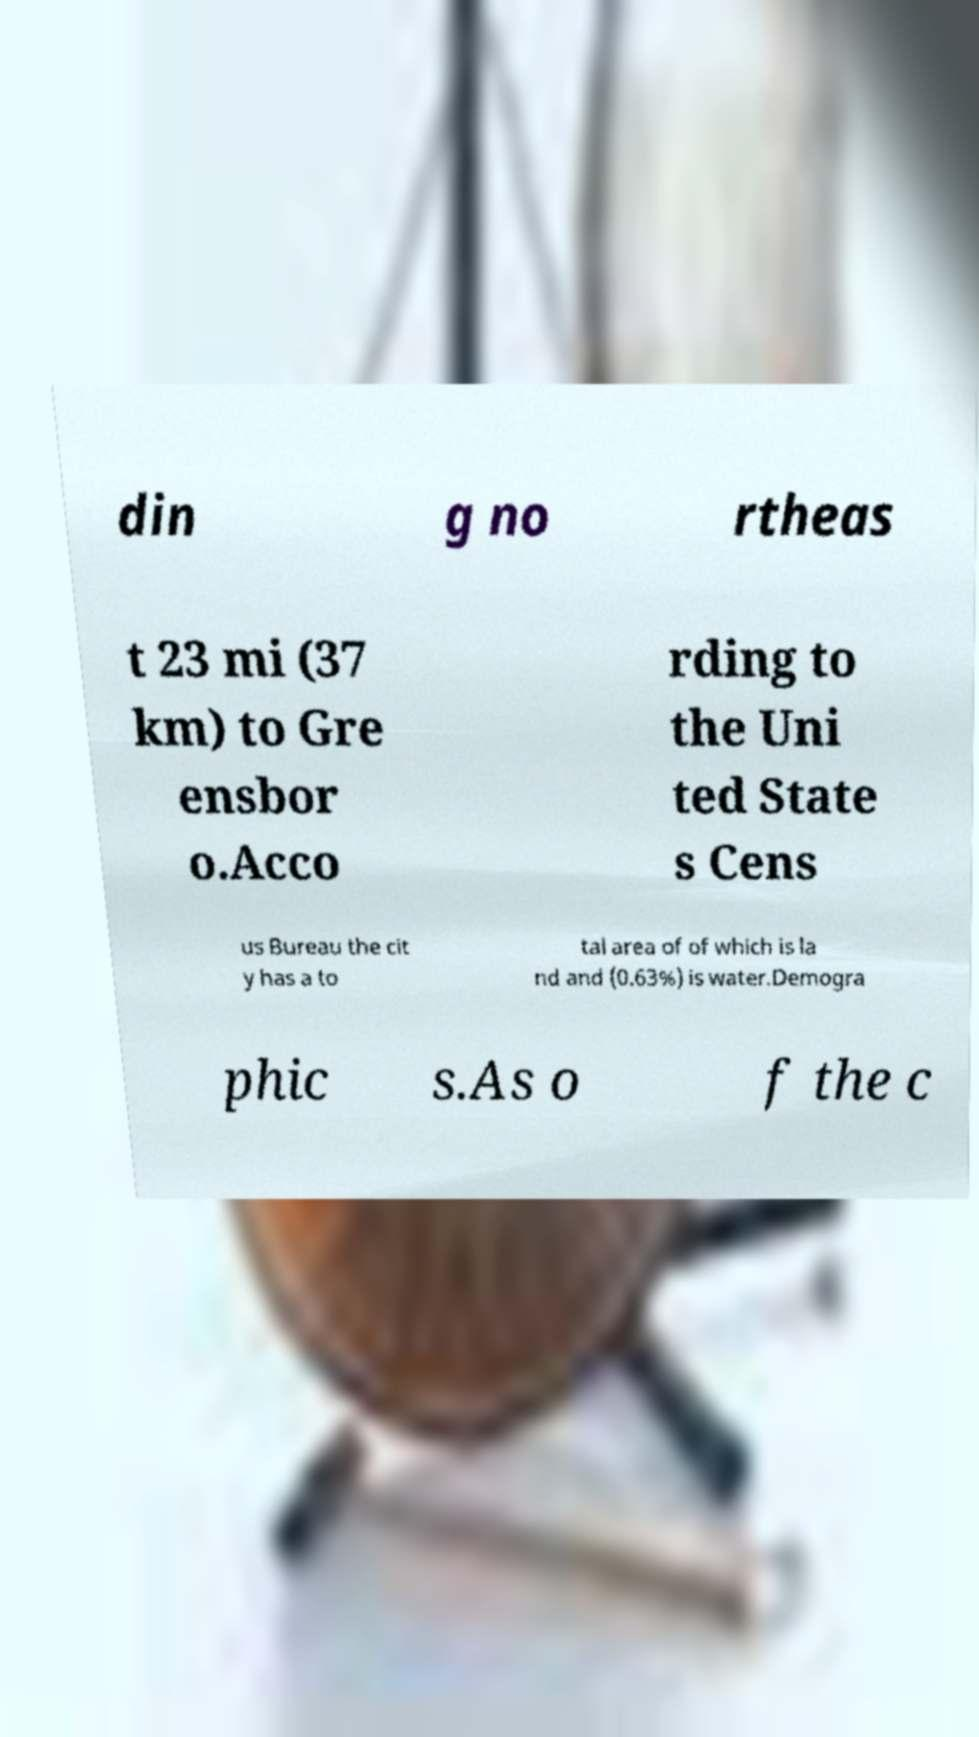Please identify and transcribe the text found in this image. din g no rtheas t 23 mi (37 km) to Gre ensbor o.Acco rding to the Uni ted State s Cens us Bureau the cit y has a to tal area of of which is la nd and (0.63%) is water.Demogra phic s.As o f the c 